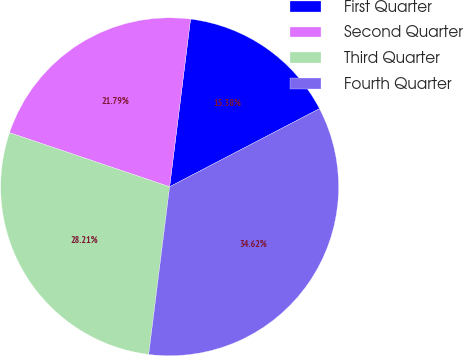Convert chart to OTSL. <chart><loc_0><loc_0><loc_500><loc_500><pie_chart><fcel>First Quarter<fcel>Second Quarter<fcel>Third Quarter<fcel>Fourth Quarter<nl><fcel>15.38%<fcel>21.79%<fcel>28.21%<fcel>34.62%<nl></chart> 